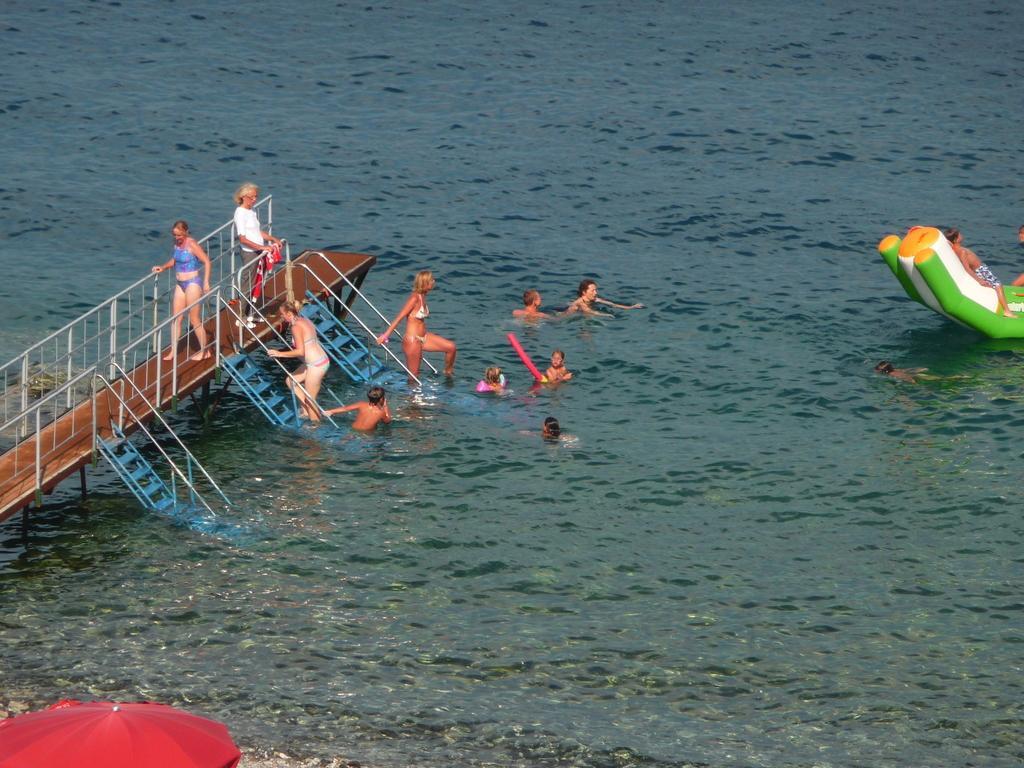Could you give a brief overview of what you see in this image? This image is taken outdoors. At the bottom of the image there is a river with water and a boat. On the left side of the image there is a bridge with railings and staircases. In the middle of the image a few are playing in the river and a few are standing on the bridge. At the bottom of the image there is an umbrella. 